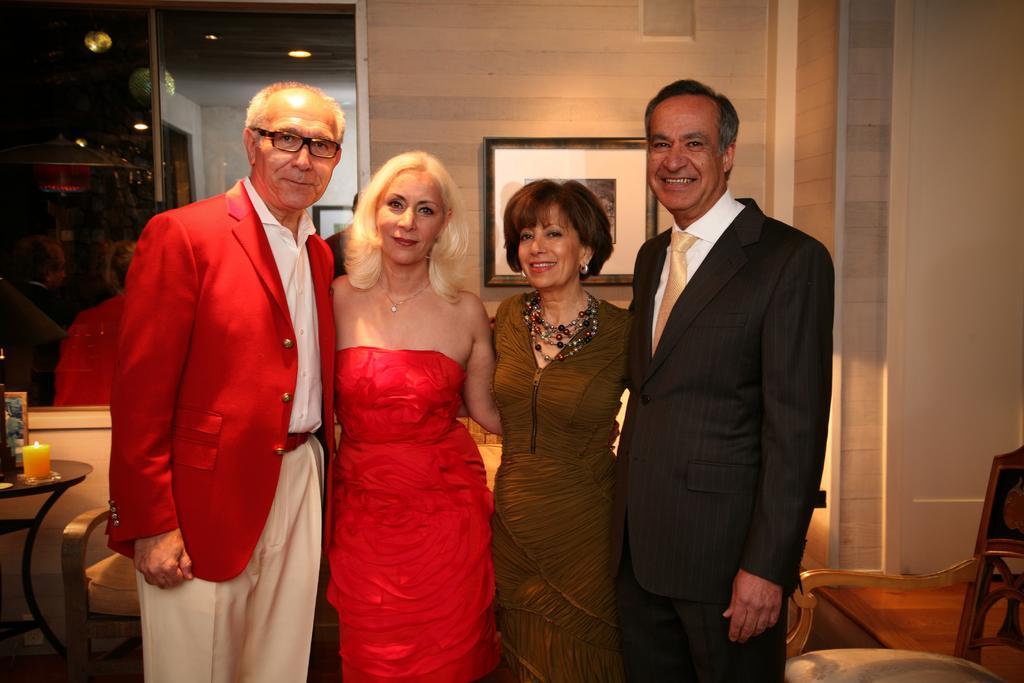In one or two sentences, can you explain what this image depicts? In this image we can see some people standing and posing for a photo in a room and there are some chairs. There is a wall with a photo frame and we can see a table with a candle and some other objects. 